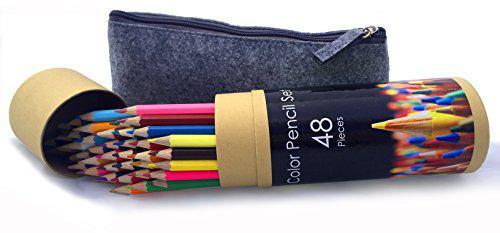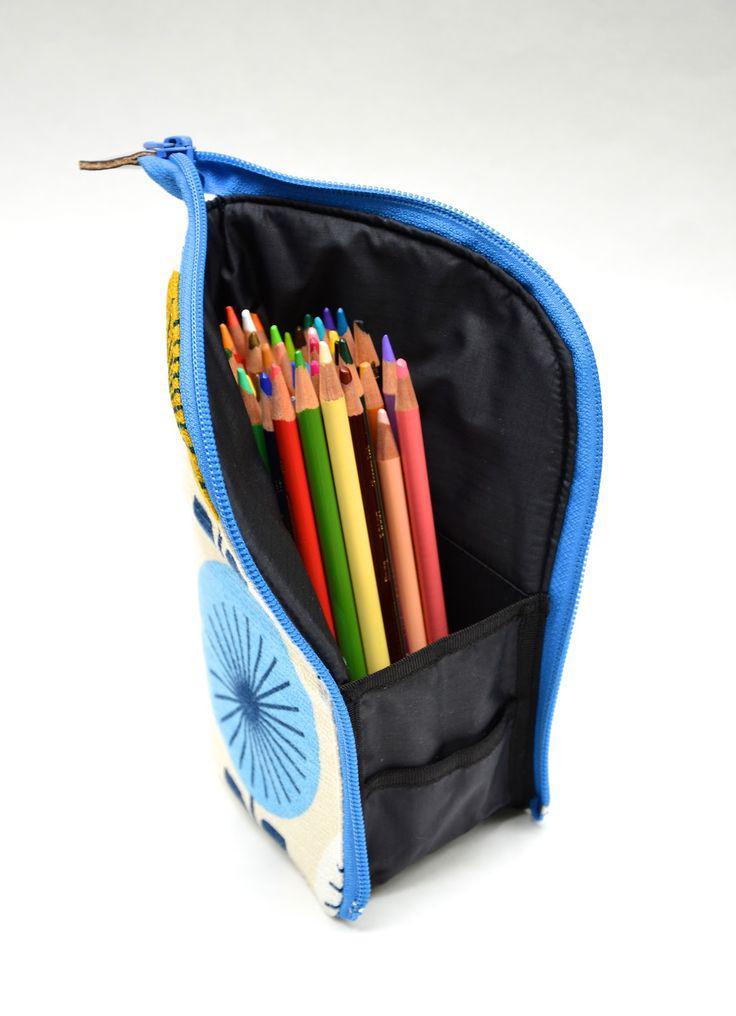The first image is the image on the left, the second image is the image on the right. Examine the images to the left and right. Is the description "The right image shows a zipper case with a graphic print on its exterior functioning as an upright holder for colored pencils." accurate? Answer yes or no. Yes. The first image is the image on the left, the second image is the image on the right. For the images displayed, is the sentence "The pens in the image on the left are near colored pencils." factually correct? Answer yes or no. No. 